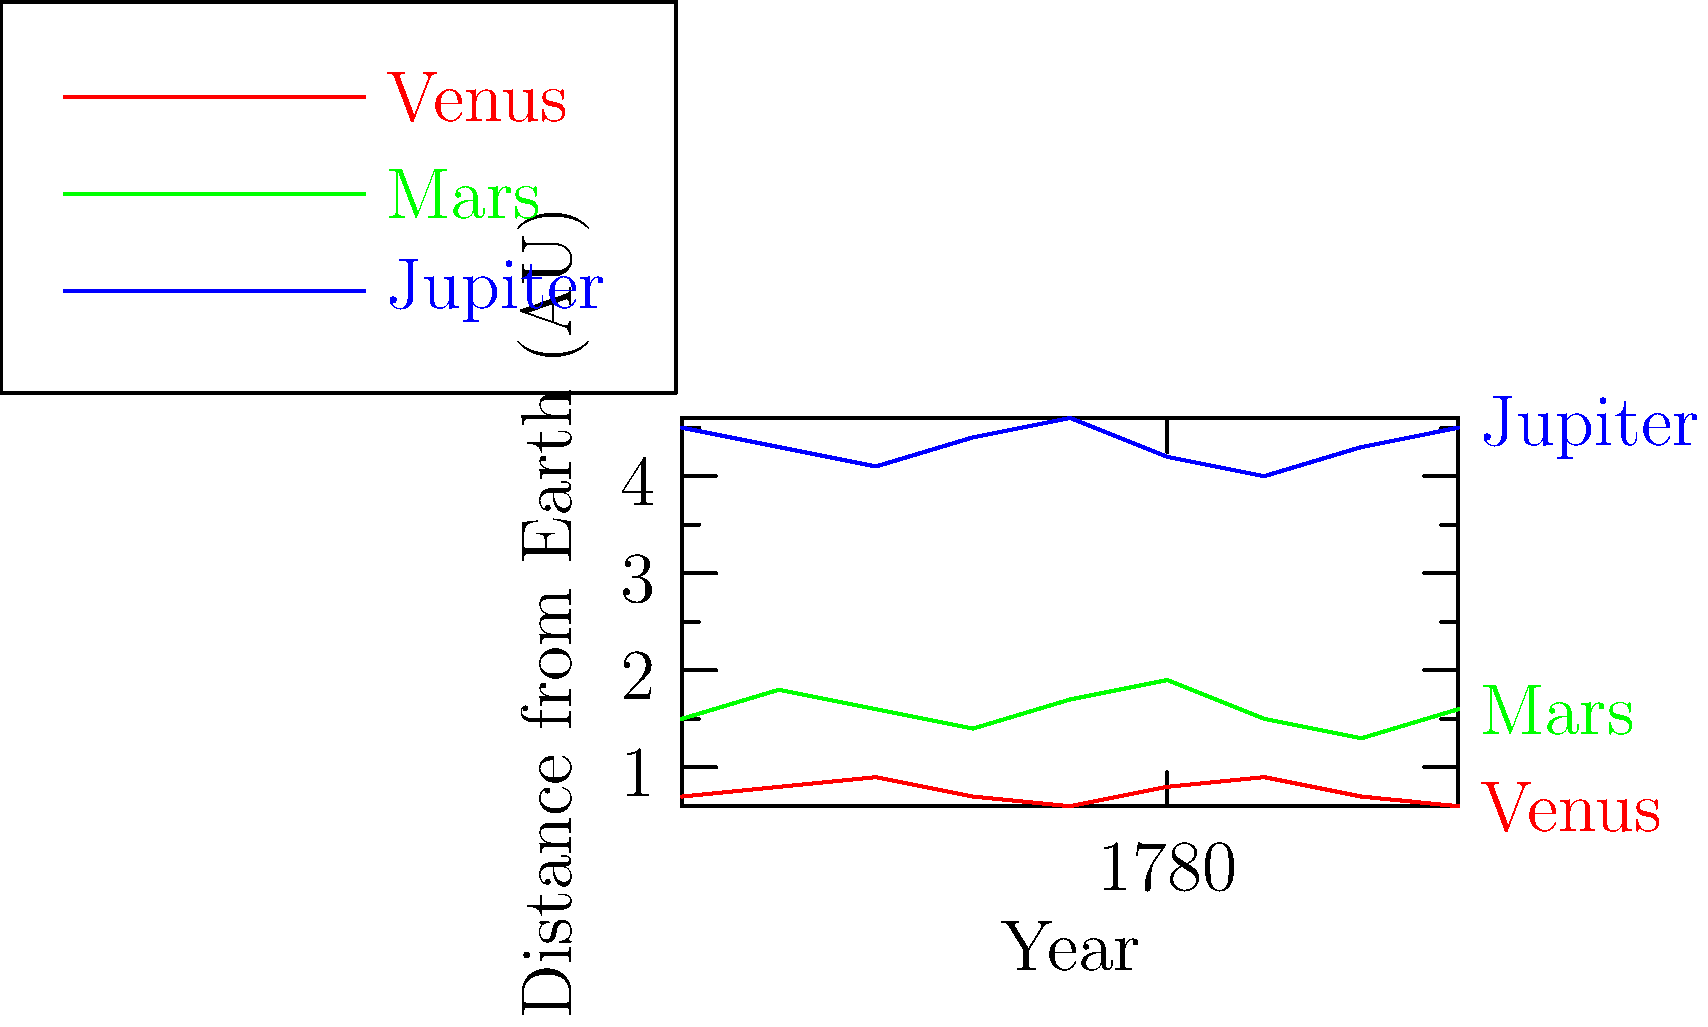Based on the graph showing the distances of Venus, Mars, and Jupiter from Earth during the American Revolutionary War (1775-1783), which planet exhibited the most consistent orbital pattern relative to Earth, and how might this have influenced astronomical observations during this pivotal historical period? To answer this question, we need to analyze the graph and consider the historical context:

1. Examine each planet's distance pattern:
   - Venus: Fluctuates between 0.6 and 0.9 AU
   - Mars: Varies widely between 1.3 and 1.9 AU
   - Jupiter: Remains between 4.0 and 4.6 AU

2. Compare the consistency of orbital patterns:
   - Jupiter shows the most consistent pattern, with relatively small variations in distance from Earth.
   - Venus and Mars exhibit more significant fluctuations.

3. Consider the implications for astronomical observations:
   - Jupiter's consistent presence would have made it a reliable celestial object for navigation and timekeeping.
   - Its steady position could have been useful for calibrating instruments and making consistent observations.

4. Historical context:
   - During the Revolutionary War, accurate navigation was crucial for both military and commercial purposes.
   - Astronomical observations were essential for determining longitude at sea.
   - Jupiter's reliability would have been valuable for sailors and military strategists alike.

5. Connection to the founding era:
   - The war coincided with advancements in scientific thought and practice.
   - Accurate astronomical observations aligned with Enlightenment ideals of reason and empiricism.
   - Jupiter's consistency could have contributed to more precise measurements and calculations during this period.
Answer: Jupiter exhibited the most consistent orbital pattern, likely aiding in navigation and timekeeping during the Revolutionary War. 